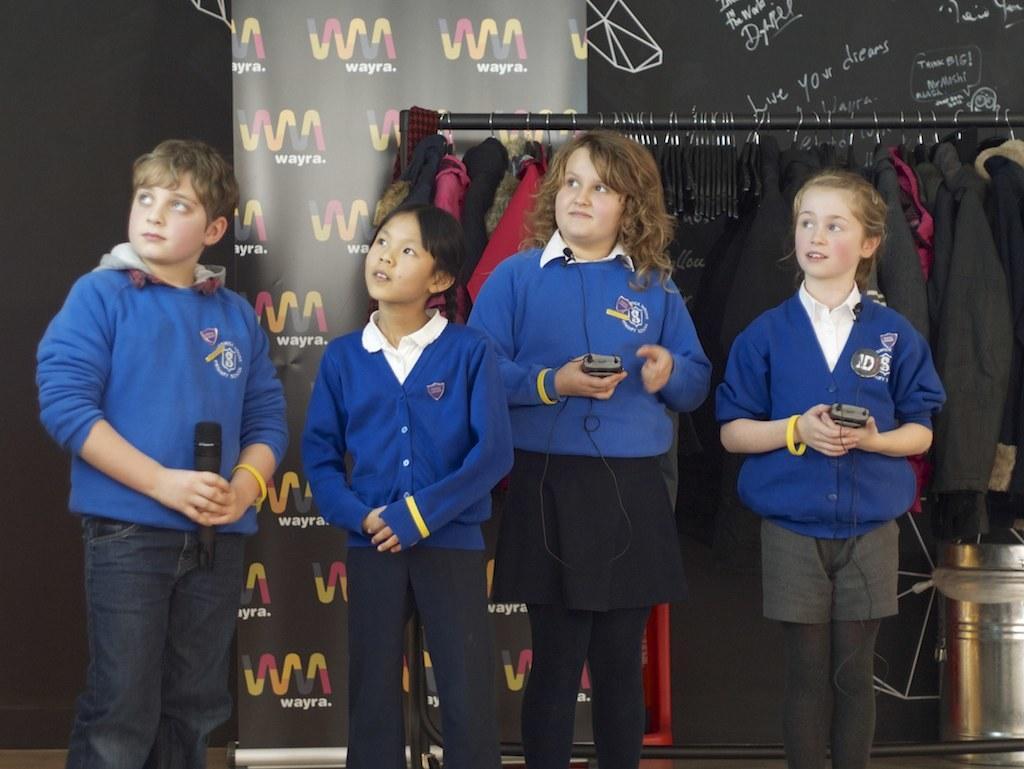Describe this image in one or two sentences. Here there is a boy and three girls standing on the floor and boy is holding a mike in his hands and the corner two girls are holding an electronic device in their hands. In the background there are clothes hanging to a pole,hoarding,some other objects and a tin on the floor. 